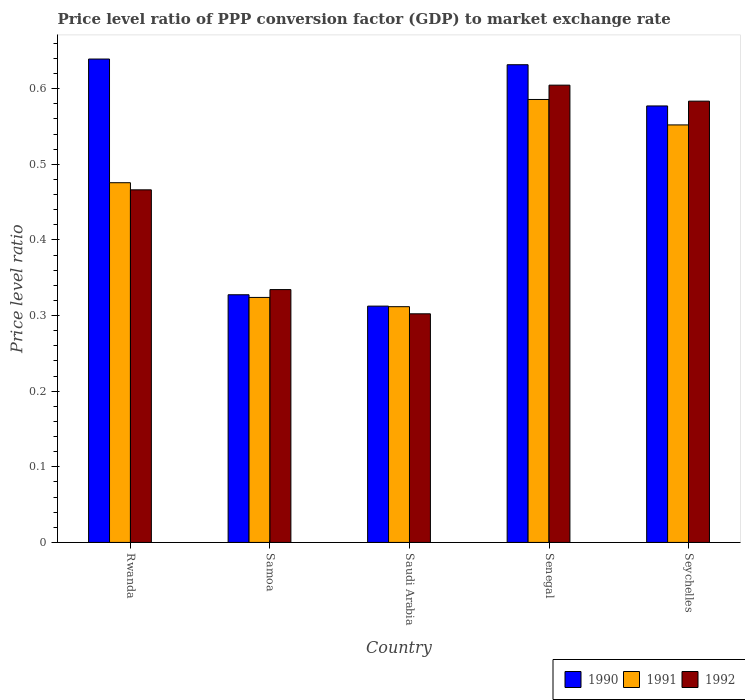What is the label of the 1st group of bars from the left?
Provide a succinct answer. Rwanda. What is the price level ratio in 1990 in Rwanda?
Provide a succinct answer. 0.64. Across all countries, what is the maximum price level ratio in 1992?
Ensure brevity in your answer.  0.6. Across all countries, what is the minimum price level ratio in 1991?
Your answer should be compact. 0.31. In which country was the price level ratio in 1991 maximum?
Provide a succinct answer. Senegal. In which country was the price level ratio in 1992 minimum?
Offer a very short reply. Saudi Arabia. What is the total price level ratio in 1990 in the graph?
Give a very brief answer. 2.49. What is the difference between the price level ratio in 1992 in Saudi Arabia and that in Seychelles?
Make the answer very short. -0.28. What is the difference between the price level ratio in 1992 in Senegal and the price level ratio in 1990 in Seychelles?
Provide a succinct answer. 0.03. What is the average price level ratio in 1991 per country?
Offer a terse response. 0.45. What is the difference between the price level ratio of/in 1991 and price level ratio of/in 1990 in Saudi Arabia?
Provide a short and direct response. -0. In how many countries, is the price level ratio in 1990 greater than 0.56?
Provide a succinct answer. 3. What is the ratio of the price level ratio in 1990 in Samoa to that in Seychelles?
Make the answer very short. 0.57. Is the price level ratio in 1992 in Samoa less than that in Seychelles?
Offer a very short reply. Yes. Is the difference between the price level ratio in 1991 in Saudi Arabia and Seychelles greater than the difference between the price level ratio in 1990 in Saudi Arabia and Seychelles?
Offer a very short reply. Yes. What is the difference between the highest and the second highest price level ratio in 1992?
Offer a terse response. 0.02. What is the difference between the highest and the lowest price level ratio in 1990?
Offer a very short reply. 0.33. In how many countries, is the price level ratio in 1990 greater than the average price level ratio in 1990 taken over all countries?
Your answer should be compact. 3. Is the sum of the price level ratio in 1991 in Saudi Arabia and Senegal greater than the maximum price level ratio in 1992 across all countries?
Your answer should be compact. Yes. What does the 1st bar from the right in Seychelles represents?
Keep it short and to the point. 1992. Is it the case that in every country, the sum of the price level ratio in 1992 and price level ratio in 1990 is greater than the price level ratio in 1991?
Make the answer very short. Yes. How many bars are there?
Your answer should be very brief. 15. How many countries are there in the graph?
Offer a terse response. 5. What is the difference between two consecutive major ticks on the Y-axis?
Provide a short and direct response. 0.1. Does the graph contain grids?
Offer a terse response. No. How many legend labels are there?
Offer a terse response. 3. What is the title of the graph?
Keep it short and to the point. Price level ratio of PPP conversion factor (GDP) to market exchange rate. What is the label or title of the X-axis?
Give a very brief answer. Country. What is the label or title of the Y-axis?
Give a very brief answer. Price level ratio. What is the Price level ratio of 1990 in Rwanda?
Offer a very short reply. 0.64. What is the Price level ratio of 1991 in Rwanda?
Your response must be concise. 0.48. What is the Price level ratio of 1992 in Rwanda?
Ensure brevity in your answer.  0.47. What is the Price level ratio in 1990 in Samoa?
Provide a short and direct response. 0.33. What is the Price level ratio in 1991 in Samoa?
Your answer should be compact. 0.32. What is the Price level ratio of 1992 in Samoa?
Provide a succinct answer. 0.33. What is the Price level ratio in 1990 in Saudi Arabia?
Your answer should be compact. 0.31. What is the Price level ratio of 1991 in Saudi Arabia?
Offer a very short reply. 0.31. What is the Price level ratio of 1992 in Saudi Arabia?
Offer a terse response. 0.3. What is the Price level ratio in 1990 in Senegal?
Provide a short and direct response. 0.63. What is the Price level ratio of 1991 in Senegal?
Provide a succinct answer. 0.59. What is the Price level ratio in 1992 in Senegal?
Your answer should be compact. 0.6. What is the Price level ratio of 1990 in Seychelles?
Offer a very short reply. 0.58. What is the Price level ratio of 1991 in Seychelles?
Keep it short and to the point. 0.55. What is the Price level ratio in 1992 in Seychelles?
Your answer should be compact. 0.58. Across all countries, what is the maximum Price level ratio in 1990?
Make the answer very short. 0.64. Across all countries, what is the maximum Price level ratio in 1991?
Your answer should be compact. 0.59. Across all countries, what is the maximum Price level ratio of 1992?
Your answer should be compact. 0.6. Across all countries, what is the minimum Price level ratio of 1990?
Your answer should be compact. 0.31. Across all countries, what is the minimum Price level ratio of 1991?
Your response must be concise. 0.31. Across all countries, what is the minimum Price level ratio in 1992?
Provide a short and direct response. 0.3. What is the total Price level ratio in 1990 in the graph?
Keep it short and to the point. 2.49. What is the total Price level ratio of 1991 in the graph?
Your answer should be compact. 2.25. What is the total Price level ratio in 1992 in the graph?
Your response must be concise. 2.29. What is the difference between the Price level ratio in 1990 in Rwanda and that in Samoa?
Your response must be concise. 0.31. What is the difference between the Price level ratio in 1991 in Rwanda and that in Samoa?
Ensure brevity in your answer.  0.15. What is the difference between the Price level ratio of 1992 in Rwanda and that in Samoa?
Keep it short and to the point. 0.13. What is the difference between the Price level ratio of 1990 in Rwanda and that in Saudi Arabia?
Give a very brief answer. 0.33. What is the difference between the Price level ratio of 1991 in Rwanda and that in Saudi Arabia?
Give a very brief answer. 0.16. What is the difference between the Price level ratio in 1992 in Rwanda and that in Saudi Arabia?
Offer a terse response. 0.16. What is the difference between the Price level ratio of 1990 in Rwanda and that in Senegal?
Give a very brief answer. 0.01. What is the difference between the Price level ratio in 1991 in Rwanda and that in Senegal?
Keep it short and to the point. -0.11. What is the difference between the Price level ratio of 1992 in Rwanda and that in Senegal?
Make the answer very short. -0.14. What is the difference between the Price level ratio in 1990 in Rwanda and that in Seychelles?
Ensure brevity in your answer.  0.06. What is the difference between the Price level ratio in 1991 in Rwanda and that in Seychelles?
Ensure brevity in your answer.  -0.08. What is the difference between the Price level ratio in 1992 in Rwanda and that in Seychelles?
Your response must be concise. -0.12. What is the difference between the Price level ratio in 1990 in Samoa and that in Saudi Arabia?
Ensure brevity in your answer.  0.01. What is the difference between the Price level ratio of 1991 in Samoa and that in Saudi Arabia?
Provide a short and direct response. 0.01. What is the difference between the Price level ratio in 1992 in Samoa and that in Saudi Arabia?
Offer a very short reply. 0.03. What is the difference between the Price level ratio in 1990 in Samoa and that in Senegal?
Offer a terse response. -0.3. What is the difference between the Price level ratio in 1991 in Samoa and that in Senegal?
Give a very brief answer. -0.26. What is the difference between the Price level ratio in 1992 in Samoa and that in Senegal?
Your answer should be compact. -0.27. What is the difference between the Price level ratio in 1990 in Samoa and that in Seychelles?
Your answer should be very brief. -0.25. What is the difference between the Price level ratio in 1991 in Samoa and that in Seychelles?
Keep it short and to the point. -0.23. What is the difference between the Price level ratio of 1992 in Samoa and that in Seychelles?
Provide a succinct answer. -0.25. What is the difference between the Price level ratio in 1990 in Saudi Arabia and that in Senegal?
Give a very brief answer. -0.32. What is the difference between the Price level ratio of 1991 in Saudi Arabia and that in Senegal?
Offer a terse response. -0.27. What is the difference between the Price level ratio in 1992 in Saudi Arabia and that in Senegal?
Your response must be concise. -0.3. What is the difference between the Price level ratio in 1990 in Saudi Arabia and that in Seychelles?
Make the answer very short. -0.26. What is the difference between the Price level ratio in 1991 in Saudi Arabia and that in Seychelles?
Provide a succinct answer. -0.24. What is the difference between the Price level ratio in 1992 in Saudi Arabia and that in Seychelles?
Ensure brevity in your answer.  -0.28. What is the difference between the Price level ratio of 1990 in Senegal and that in Seychelles?
Offer a very short reply. 0.05. What is the difference between the Price level ratio in 1991 in Senegal and that in Seychelles?
Your answer should be compact. 0.03. What is the difference between the Price level ratio of 1992 in Senegal and that in Seychelles?
Your answer should be very brief. 0.02. What is the difference between the Price level ratio of 1990 in Rwanda and the Price level ratio of 1991 in Samoa?
Keep it short and to the point. 0.32. What is the difference between the Price level ratio in 1990 in Rwanda and the Price level ratio in 1992 in Samoa?
Your answer should be very brief. 0.3. What is the difference between the Price level ratio of 1991 in Rwanda and the Price level ratio of 1992 in Samoa?
Offer a terse response. 0.14. What is the difference between the Price level ratio in 1990 in Rwanda and the Price level ratio in 1991 in Saudi Arabia?
Keep it short and to the point. 0.33. What is the difference between the Price level ratio of 1990 in Rwanda and the Price level ratio of 1992 in Saudi Arabia?
Make the answer very short. 0.34. What is the difference between the Price level ratio of 1991 in Rwanda and the Price level ratio of 1992 in Saudi Arabia?
Offer a very short reply. 0.17. What is the difference between the Price level ratio in 1990 in Rwanda and the Price level ratio in 1991 in Senegal?
Your response must be concise. 0.05. What is the difference between the Price level ratio of 1990 in Rwanda and the Price level ratio of 1992 in Senegal?
Offer a terse response. 0.03. What is the difference between the Price level ratio in 1991 in Rwanda and the Price level ratio in 1992 in Senegal?
Make the answer very short. -0.13. What is the difference between the Price level ratio of 1990 in Rwanda and the Price level ratio of 1991 in Seychelles?
Offer a very short reply. 0.09. What is the difference between the Price level ratio of 1990 in Rwanda and the Price level ratio of 1992 in Seychelles?
Your answer should be compact. 0.06. What is the difference between the Price level ratio in 1991 in Rwanda and the Price level ratio in 1992 in Seychelles?
Keep it short and to the point. -0.11. What is the difference between the Price level ratio of 1990 in Samoa and the Price level ratio of 1991 in Saudi Arabia?
Your response must be concise. 0.02. What is the difference between the Price level ratio of 1990 in Samoa and the Price level ratio of 1992 in Saudi Arabia?
Offer a very short reply. 0.03. What is the difference between the Price level ratio in 1991 in Samoa and the Price level ratio in 1992 in Saudi Arabia?
Provide a succinct answer. 0.02. What is the difference between the Price level ratio of 1990 in Samoa and the Price level ratio of 1991 in Senegal?
Offer a very short reply. -0.26. What is the difference between the Price level ratio in 1990 in Samoa and the Price level ratio in 1992 in Senegal?
Your response must be concise. -0.28. What is the difference between the Price level ratio in 1991 in Samoa and the Price level ratio in 1992 in Senegal?
Provide a succinct answer. -0.28. What is the difference between the Price level ratio in 1990 in Samoa and the Price level ratio in 1991 in Seychelles?
Provide a short and direct response. -0.22. What is the difference between the Price level ratio of 1990 in Samoa and the Price level ratio of 1992 in Seychelles?
Provide a succinct answer. -0.26. What is the difference between the Price level ratio of 1991 in Samoa and the Price level ratio of 1992 in Seychelles?
Offer a very short reply. -0.26. What is the difference between the Price level ratio of 1990 in Saudi Arabia and the Price level ratio of 1991 in Senegal?
Provide a succinct answer. -0.27. What is the difference between the Price level ratio in 1990 in Saudi Arabia and the Price level ratio in 1992 in Senegal?
Your answer should be very brief. -0.29. What is the difference between the Price level ratio of 1991 in Saudi Arabia and the Price level ratio of 1992 in Senegal?
Offer a very short reply. -0.29. What is the difference between the Price level ratio in 1990 in Saudi Arabia and the Price level ratio in 1991 in Seychelles?
Offer a very short reply. -0.24. What is the difference between the Price level ratio in 1990 in Saudi Arabia and the Price level ratio in 1992 in Seychelles?
Offer a very short reply. -0.27. What is the difference between the Price level ratio in 1991 in Saudi Arabia and the Price level ratio in 1992 in Seychelles?
Your response must be concise. -0.27. What is the difference between the Price level ratio of 1990 in Senegal and the Price level ratio of 1991 in Seychelles?
Provide a short and direct response. 0.08. What is the difference between the Price level ratio of 1990 in Senegal and the Price level ratio of 1992 in Seychelles?
Your answer should be very brief. 0.05. What is the difference between the Price level ratio in 1991 in Senegal and the Price level ratio in 1992 in Seychelles?
Give a very brief answer. 0. What is the average Price level ratio in 1990 per country?
Keep it short and to the point. 0.5. What is the average Price level ratio in 1991 per country?
Give a very brief answer. 0.45. What is the average Price level ratio in 1992 per country?
Provide a short and direct response. 0.46. What is the difference between the Price level ratio in 1990 and Price level ratio in 1991 in Rwanda?
Your answer should be compact. 0.16. What is the difference between the Price level ratio of 1990 and Price level ratio of 1992 in Rwanda?
Offer a terse response. 0.17. What is the difference between the Price level ratio in 1991 and Price level ratio in 1992 in Rwanda?
Offer a terse response. 0.01. What is the difference between the Price level ratio of 1990 and Price level ratio of 1991 in Samoa?
Keep it short and to the point. 0. What is the difference between the Price level ratio in 1990 and Price level ratio in 1992 in Samoa?
Your answer should be very brief. -0.01. What is the difference between the Price level ratio in 1991 and Price level ratio in 1992 in Samoa?
Provide a short and direct response. -0.01. What is the difference between the Price level ratio in 1990 and Price level ratio in 1991 in Saudi Arabia?
Provide a succinct answer. 0. What is the difference between the Price level ratio of 1990 and Price level ratio of 1992 in Saudi Arabia?
Your answer should be compact. 0.01. What is the difference between the Price level ratio of 1991 and Price level ratio of 1992 in Saudi Arabia?
Your answer should be very brief. 0.01. What is the difference between the Price level ratio in 1990 and Price level ratio in 1991 in Senegal?
Provide a succinct answer. 0.05. What is the difference between the Price level ratio of 1990 and Price level ratio of 1992 in Senegal?
Provide a succinct answer. 0.03. What is the difference between the Price level ratio of 1991 and Price level ratio of 1992 in Senegal?
Provide a succinct answer. -0.02. What is the difference between the Price level ratio of 1990 and Price level ratio of 1991 in Seychelles?
Your response must be concise. 0.03. What is the difference between the Price level ratio of 1990 and Price level ratio of 1992 in Seychelles?
Keep it short and to the point. -0.01. What is the difference between the Price level ratio of 1991 and Price level ratio of 1992 in Seychelles?
Provide a succinct answer. -0.03. What is the ratio of the Price level ratio in 1990 in Rwanda to that in Samoa?
Make the answer very short. 1.95. What is the ratio of the Price level ratio of 1991 in Rwanda to that in Samoa?
Provide a short and direct response. 1.47. What is the ratio of the Price level ratio of 1992 in Rwanda to that in Samoa?
Give a very brief answer. 1.39. What is the ratio of the Price level ratio in 1990 in Rwanda to that in Saudi Arabia?
Ensure brevity in your answer.  2.05. What is the ratio of the Price level ratio of 1991 in Rwanda to that in Saudi Arabia?
Ensure brevity in your answer.  1.53. What is the ratio of the Price level ratio in 1992 in Rwanda to that in Saudi Arabia?
Give a very brief answer. 1.54. What is the ratio of the Price level ratio in 1990 in Rwanda to that in Senegal?
Keep it short and to the point. 1.01. What is the ratio of the Price level ratio of 1991 in Rwanda to that in Senegal?
Offer a terse response. 0.81. What is the ratio of the Price level ratio of 1992 in Rwanda to that in Senegal?
Give a very brief answer. 0.77. What is the ratio of the Price level ratio in 1990 in Rwanda to that in Seychelles?
Make the answer very short. 1.11. What is the ratio of the Price level ratio of 1991 in Rwanda to that in Seychelles?
Your response must be concise. 0.86. What is the ratio of the Price level ratio in 1992 in Rwanda to that in Seychelles?
Make the answer very short. 0.8. What is the ratio of the Price level ratio of 1990 in Samoa to that in Saudi Arabia?
Offer a terse response. 1.05. What is the ratio of the Price level ratio in 1991 in Samoa to that in Saudi Arabia?
Your response must be concise. 1.04. What is the ratio of the Price level ratio of 1992 in Samoa to that in Saudi Arabia?
Provide a short and direct response. 1.11. What is the ratio of the Price level ratio of 1990 in Samoa to that in Senegal?
Give a very brief answer. 0.52. What is the ratio of the Price level ratio in 1991 in Samoa to that in Senegal?
Make the answer very short. 0.55. What is the ratio of the Price level ratio of 1992 in Samoa to that in Senegal?
Your answer should be very brief. 0.55. What is the ratio of the Price level ratio of 1990 in Samoa to that in Seychelles?
Provide a succinct answer. 0.57. What is the ratio of the Price level ratio of 1991 in Samoa to that in Seychelles?
Your response must be concise. 0.59. What is the ratio of the Price level ratio of 1992 in Samoa to that in Seychelles?
Your answer should be very brief. 0.57. What is the ratio of the Price level ratio in 1990 in Saudi Arabia to that in Senegal?
Offer a very short reply. 0.49. What is the ratio of the Price level ratio of 1991 in Saudi Arabia to that in Senegal?
Offer a very short reply. 0.53. What is the ratio of the Price level ratio of 1992 in Saudi Arabia to that in Senegal?
Give a very brief answer. 0.5. What is the ratio of the Price level ratio in 1990 in Saudi Arabia to that in Seychelles?
Your answer should be compact. 0.54. What is the ratio of the Price level ratio of 1991 in Saudi Arabia to that in Seychelles?
Ensure brevity in your answer.  0.56. What is the ratio of the Price level ratio of 1992 in Saudi Arabia to that in Seychelles?
Offer a very short reply. 0.52. What is the ratio of the Price level ratio of 1990 in Senegal to that in Seychelles?
Offer a very short reply. 1.09. What is the ratio of the Price level ratio in 1991 in Senegal to that in Seychelles?
Your response must be concise. 1.06. What is the ratio of the Price level ratio in 1992 in Senegal to that in Seychelles?
Provide a short and direct response. 1.04. What is the difference between the highest and the second highest Price level ratio of 1990?
Give a very brief answer. 0.01. What is the difference between the highest and the second highest Price level ratio of 1991?
Make the answer very short. 0.03. What is the difference between the highest and the second highest Price level ratio of 1992?
Your answer should be compact. 0.02. What is the difference between the highest and the lowest Price level ratio in 1990?
Make the answer very short. 0.33. What is the difference between the highest and the lowest Price level ratio of 1991?
Provide a succinct answer. 0.27. What is the difference between the highest and the lowest Price level ratio of 1992?
Your answer should be compact. 0.3. 